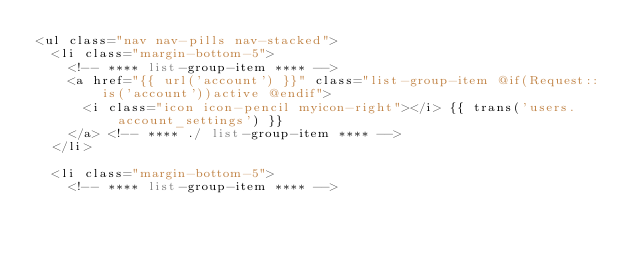Convert code to text. <code><loc_0><loc_0><loc_500><loc_500><_PHP_><ul class="nav nav-pills nav-stacked">
	<li class="margin-bottom-5">
		<!-- **** list-group-item **** -->	
		<a href="{{ url('account') }}" class="list-group-item @if(Request::is('account'))active @endif"> 
			<i class="icon icon-pencil myicon-right"></i> {{ trans('users.account_settings') }} 
		</a> <!-- **** ./ list-group-item **** -->
	</li>

	<li class="margin-bottom-5">
		<!-- **** list-group-item **** -->	</code> 